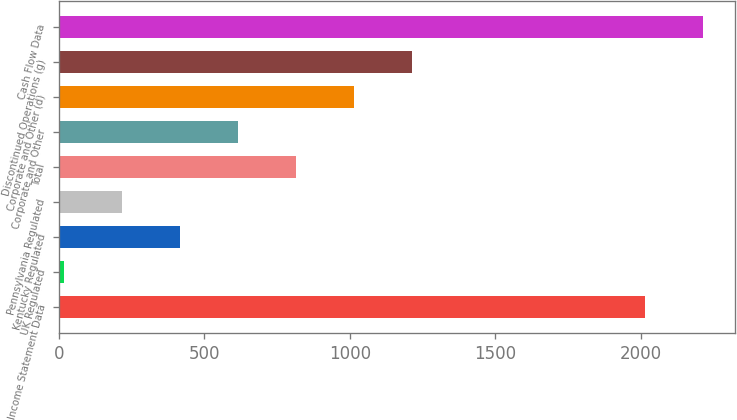Convert chart. <chart><loc_0><loc_0><loc_500><loc_500><bar_chart><fcel>Income Statement Data<fcel>UK Regulated<fcel>Kentucky Regulated<fcel>Pennsylvania Regulated<fcel>Total<fcel>Corporate and Other<fcel>Corporate and Other (d)<fcel>Discontinued Operations (g)<fcel>Cash Flow Data<nl><fcel>2013<fcel>19<fcel>417.8<fcel>218.4<fcel>816.6<fcel>617.2<fcel>1016<fcel>1215.4<fcel>2212.4<nl></chart> 